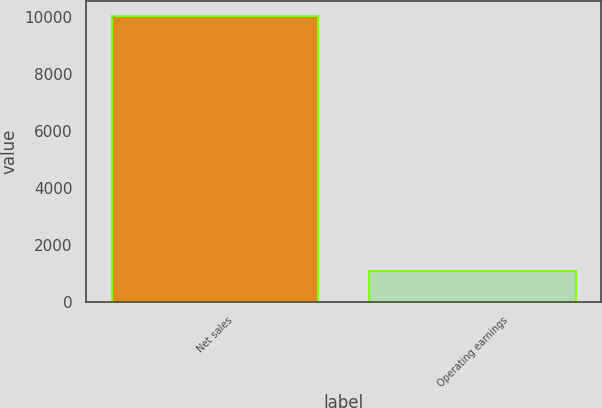<chart> <loc_0><loc_0><loc_500><loc_500><bar_chart><fcel>Net sales<fcel>Operating earnings<nl><fcel>10038<fcel>1075<nl></chart> 